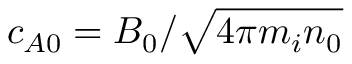<formula> <loc_0><loc_0><loc_500><loc_500>c _ { A 0 } = B _ { 0 } / \sqrt { 4 \pi m _ { i } n _ { 0 } }</formula> 